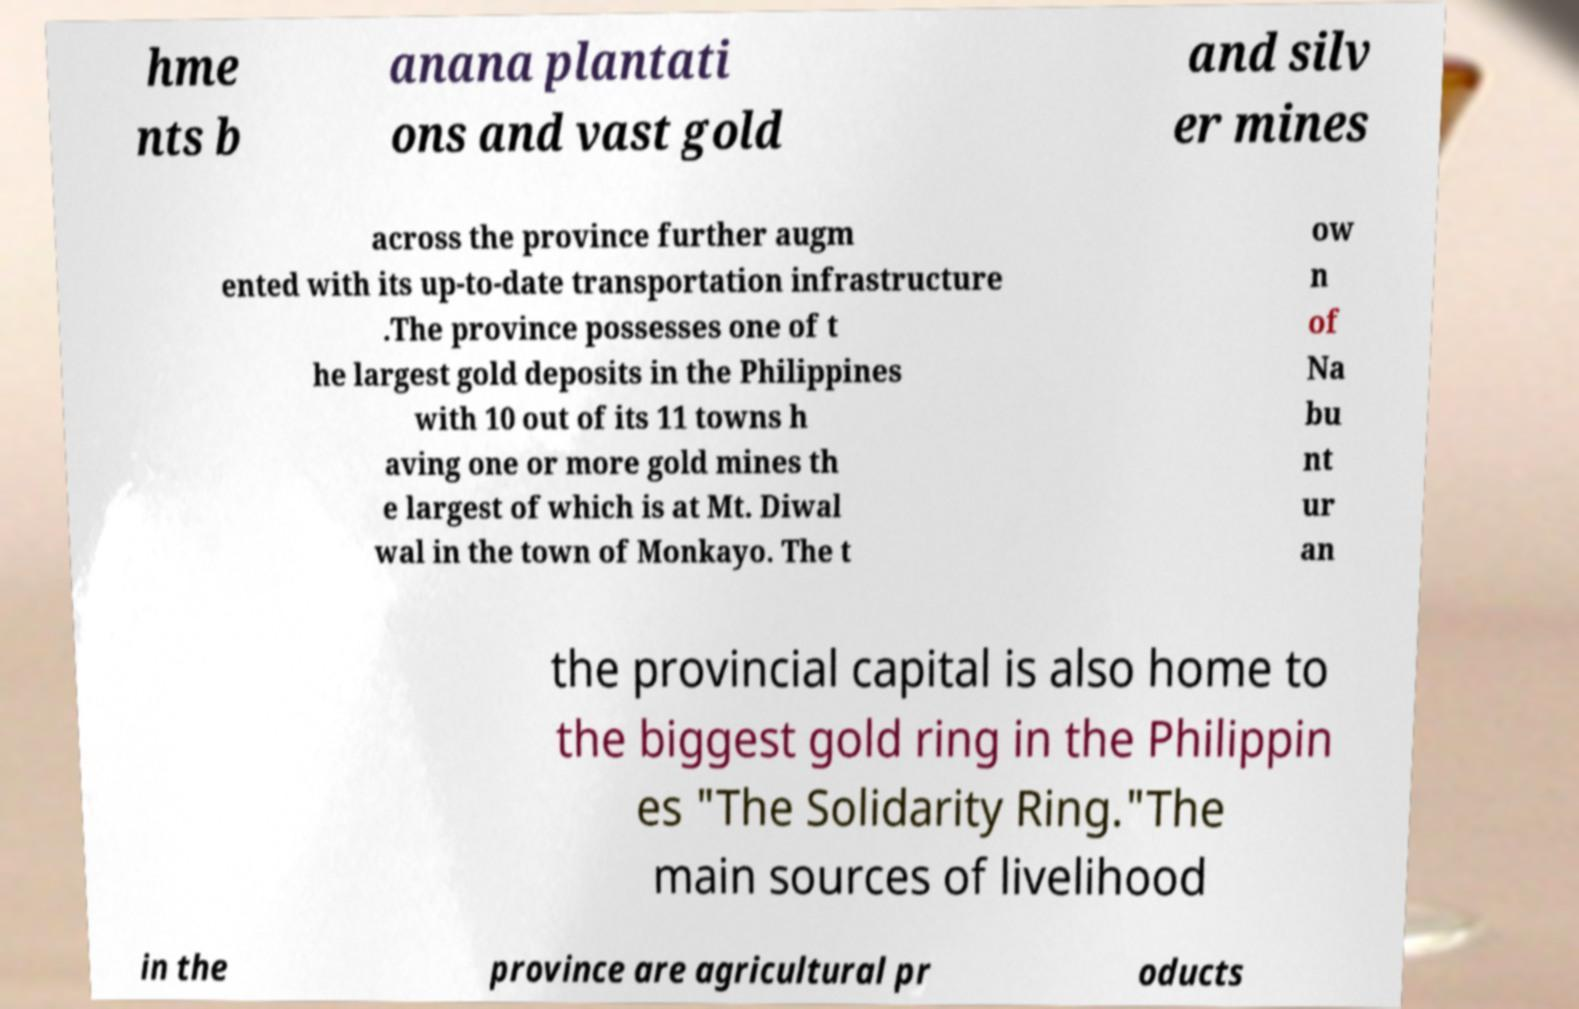There's text embedded in this image that I need extracted. Can you transcribe it verbatim? hme nts b anana plantati ons and vast gold and silv er mines across the province further augm ented with its up-to-date transportation infrastructure .The province possesses one of t he largest gold deposits in the Philippines with 10 out of its 11 towns h aving one or more gold mines th e largest of which is at Mt. Diwal wal in the town of Monkayo. The t ow n of Na bu nt ur an the provincial capital is also home to the biggest gold ring in the Philippin es "The Solidarity Ring."The main sources of livelihood in the province are agricultural pr oducts 